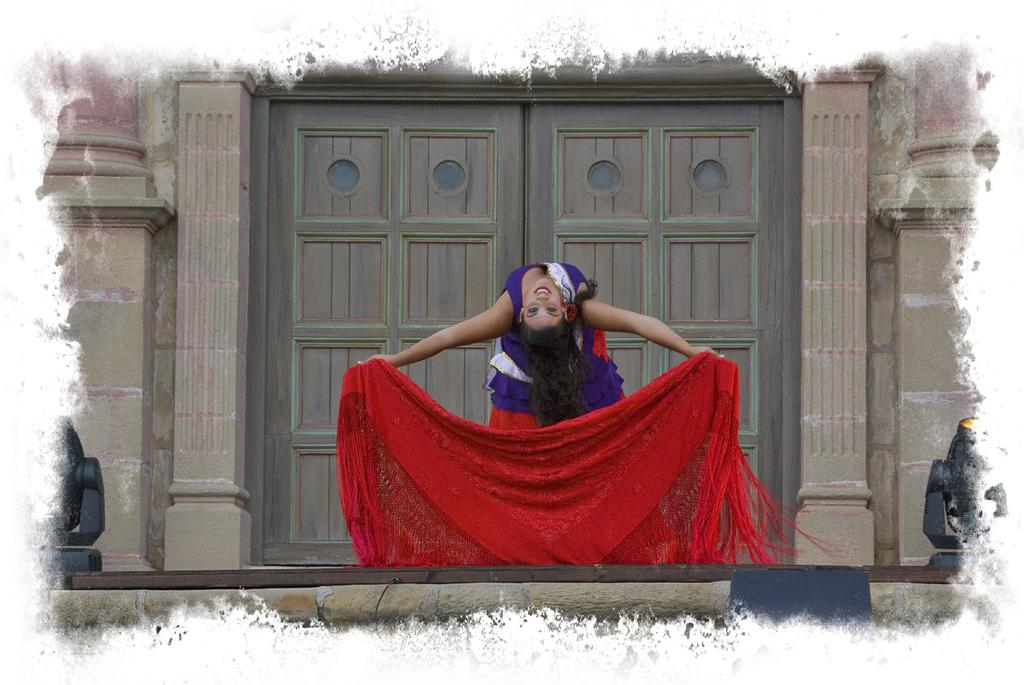Who is the main subject in the image? There is a girl in the image. What is the girl doing in the image? The girl is standing in front of a door and bending back. What is the girl holding in the image? The girl is holding a scarf. What type of dinosaurs can be seen in the image? There are no dinosaurs present in the image; it features a girl standing in front of a door and holding a scarf. What color is the gold object in the image? There is no gold object present in the image. 